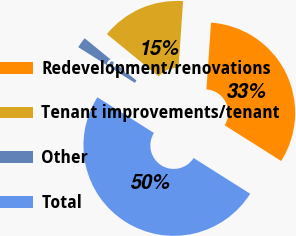<chart> <loc_0><loc_0><loc_500><loc_500><pie_chart><fcel>Redevelopment/renovations<fcel>Tenant improvements/tenant<fcel>Other<fcel>Total<nl><fcel>32.87%<fcel>15.2%<fcel>1.93%<fcel>50.0%<nl></chart> 